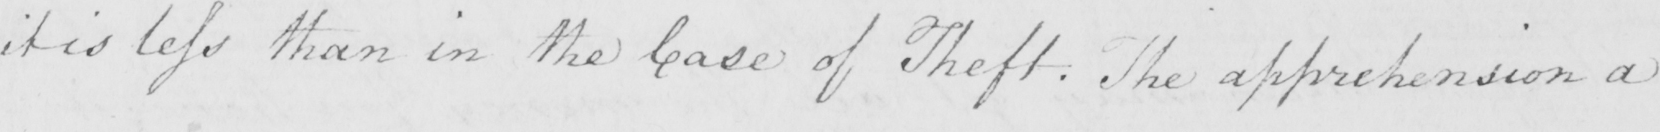What text is written in this handwritten line? it is less than in the case of Theft . The apprehension a 